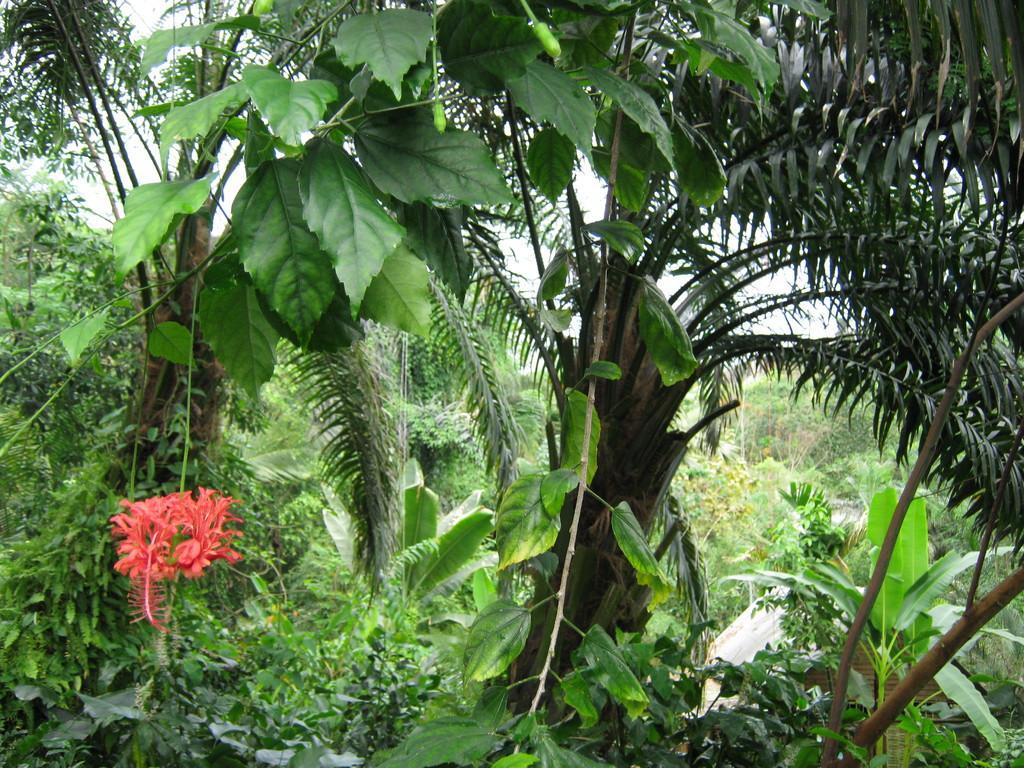How would you summarize this image in a sentence or two? In this image, we can see trees and there are plants along with flowers and buds. 